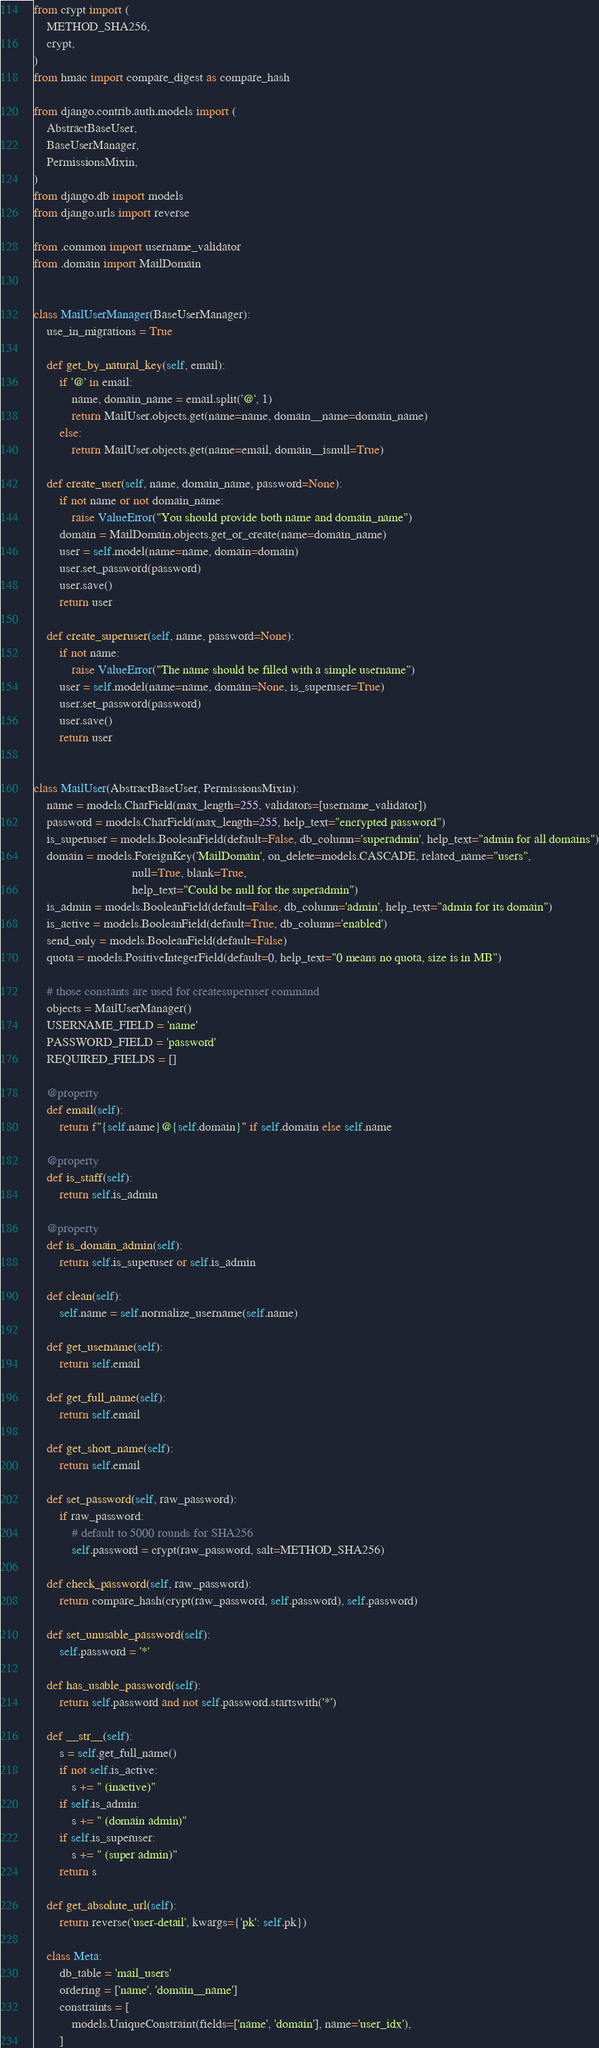Convert code to text. <code><loc_0><loc_0><loc_500><loc_500><_Python_>from crypt import (
    METHOD_SHA256,
    crypt,
)
from hmac import compare_digest as compare_hash

from django.contrib.auth.models import (
    AbstractBaseUser,
    BaseUserManager,
    PermissionsMixin,
)
from django.db import models
from django.urls import reverse

from .common import username_validator
from .domain import MailDomain


class MailUserManager(BaseUserManager):
    use_in_migrations = True

    def get_by_natural_key(self, email):
        if '@' in email:
            name, domain_name = email.split('@', 1)
            return MailUser.objects.get(name=name, domain__name=domain_name)
        else:
            return MailUser.objects.get(name=email, domain__isnull=True)

    def create_user(self, name, domain_name, password=None):
        if not name or not domain_name:
            raise ValueError("You should provide both name and domain_name")
        domain = MailDomain.objects.get_or_create(name=domain_name)
        user = self.model(name=name, domain=domain)
        user.set_password(password)
        user.save()
        return user

    def create_superuser(self, name, password=None):
        if not name:
            raise ValueError("The name should be filled with a simple username")
        user = self.model(name=name, domain=None, is_superuser=True)
        user.set_password(password)
        user.save()
        return user


class MailUser(AbstractBaseUser, PermissionsMixin):
    name = models.CharField(max_length=255, validators=[username_validator])
    password = models.CharField(max_length=255, help_text="encrypted password")
    is_superuser = models.BooleanField(default=False, db_column='superadmin', help_text="admin for all domains")
    domain = models.ForeignKey('MailDomain', on_delete=models.CASCADE, related_name="users",
                               null=True, blank=True,
                               help_text="Could be null for the superadmin")
    is_admin = models.BooleanField(default=False, db_column='admin', help_text="admin for its domain")
    is_active = models.BooleanField(default=True, db_column='enabled')
    send_only = models.BooleanField(default=False)
    quota = models.PositiveIntegerField(default=0, help_text="0 means no quota, size is in MB")

    # those constants are used for createsuperuser command
    objects = MailUserManager()
    USERNAME_FIELD = 'name'
    PASSWORD_FIELD = 'password'
    REQUIRED_FIELDS = []

    @property
    def email(self):
        return f"{self.name}@{self.domain}" if self.domain else self.name

    @property
    def is_staff(self):
        return self.is_admin

    @property
    def is_domain_admin(self):
        return self.is_superuser or self.is_admin

    def clean(self):
        self.name = self.normalize_username(self.name)

    def get_username(self):
        return self.email

    def get_full_name(self):
        return self.email

    def get_short_name(self):
        return self.email

    def set_password(self, raw_password):
        if raw_password:
            # default to 5000 rounds for SHA256
            self.password = crypt(raw_password, salt=METHOD_SHA256)

    def check_password(self, raw_password):
        return compare_hash(crypt(raw_password, self.password), self.password)

    def set_unusable_password(self):
        self.password = '*'

    def has_usable_password(self):
        return self.password and not self.password.startswith('*')

    def __str__(self):
        s = self.get_full_name()
        if not self.is_active:
            s += " (inactive)"
        if self.is_admin:
            s += " (domain admin)"
        if self.is_superuser:
            s += " (super admin)"
        return s

    def get_absolute_url(self):
        return reverse('user-detail', kwargs={'pk': self.pk})

    class Meta:
        db_table = 'mail_users'
        ordering = ['name', 'domain__name']
        constraints = [
            models.UniqueConstraint(fields=['name', 'domain'], name='user_idx'),
        ]
</code> 